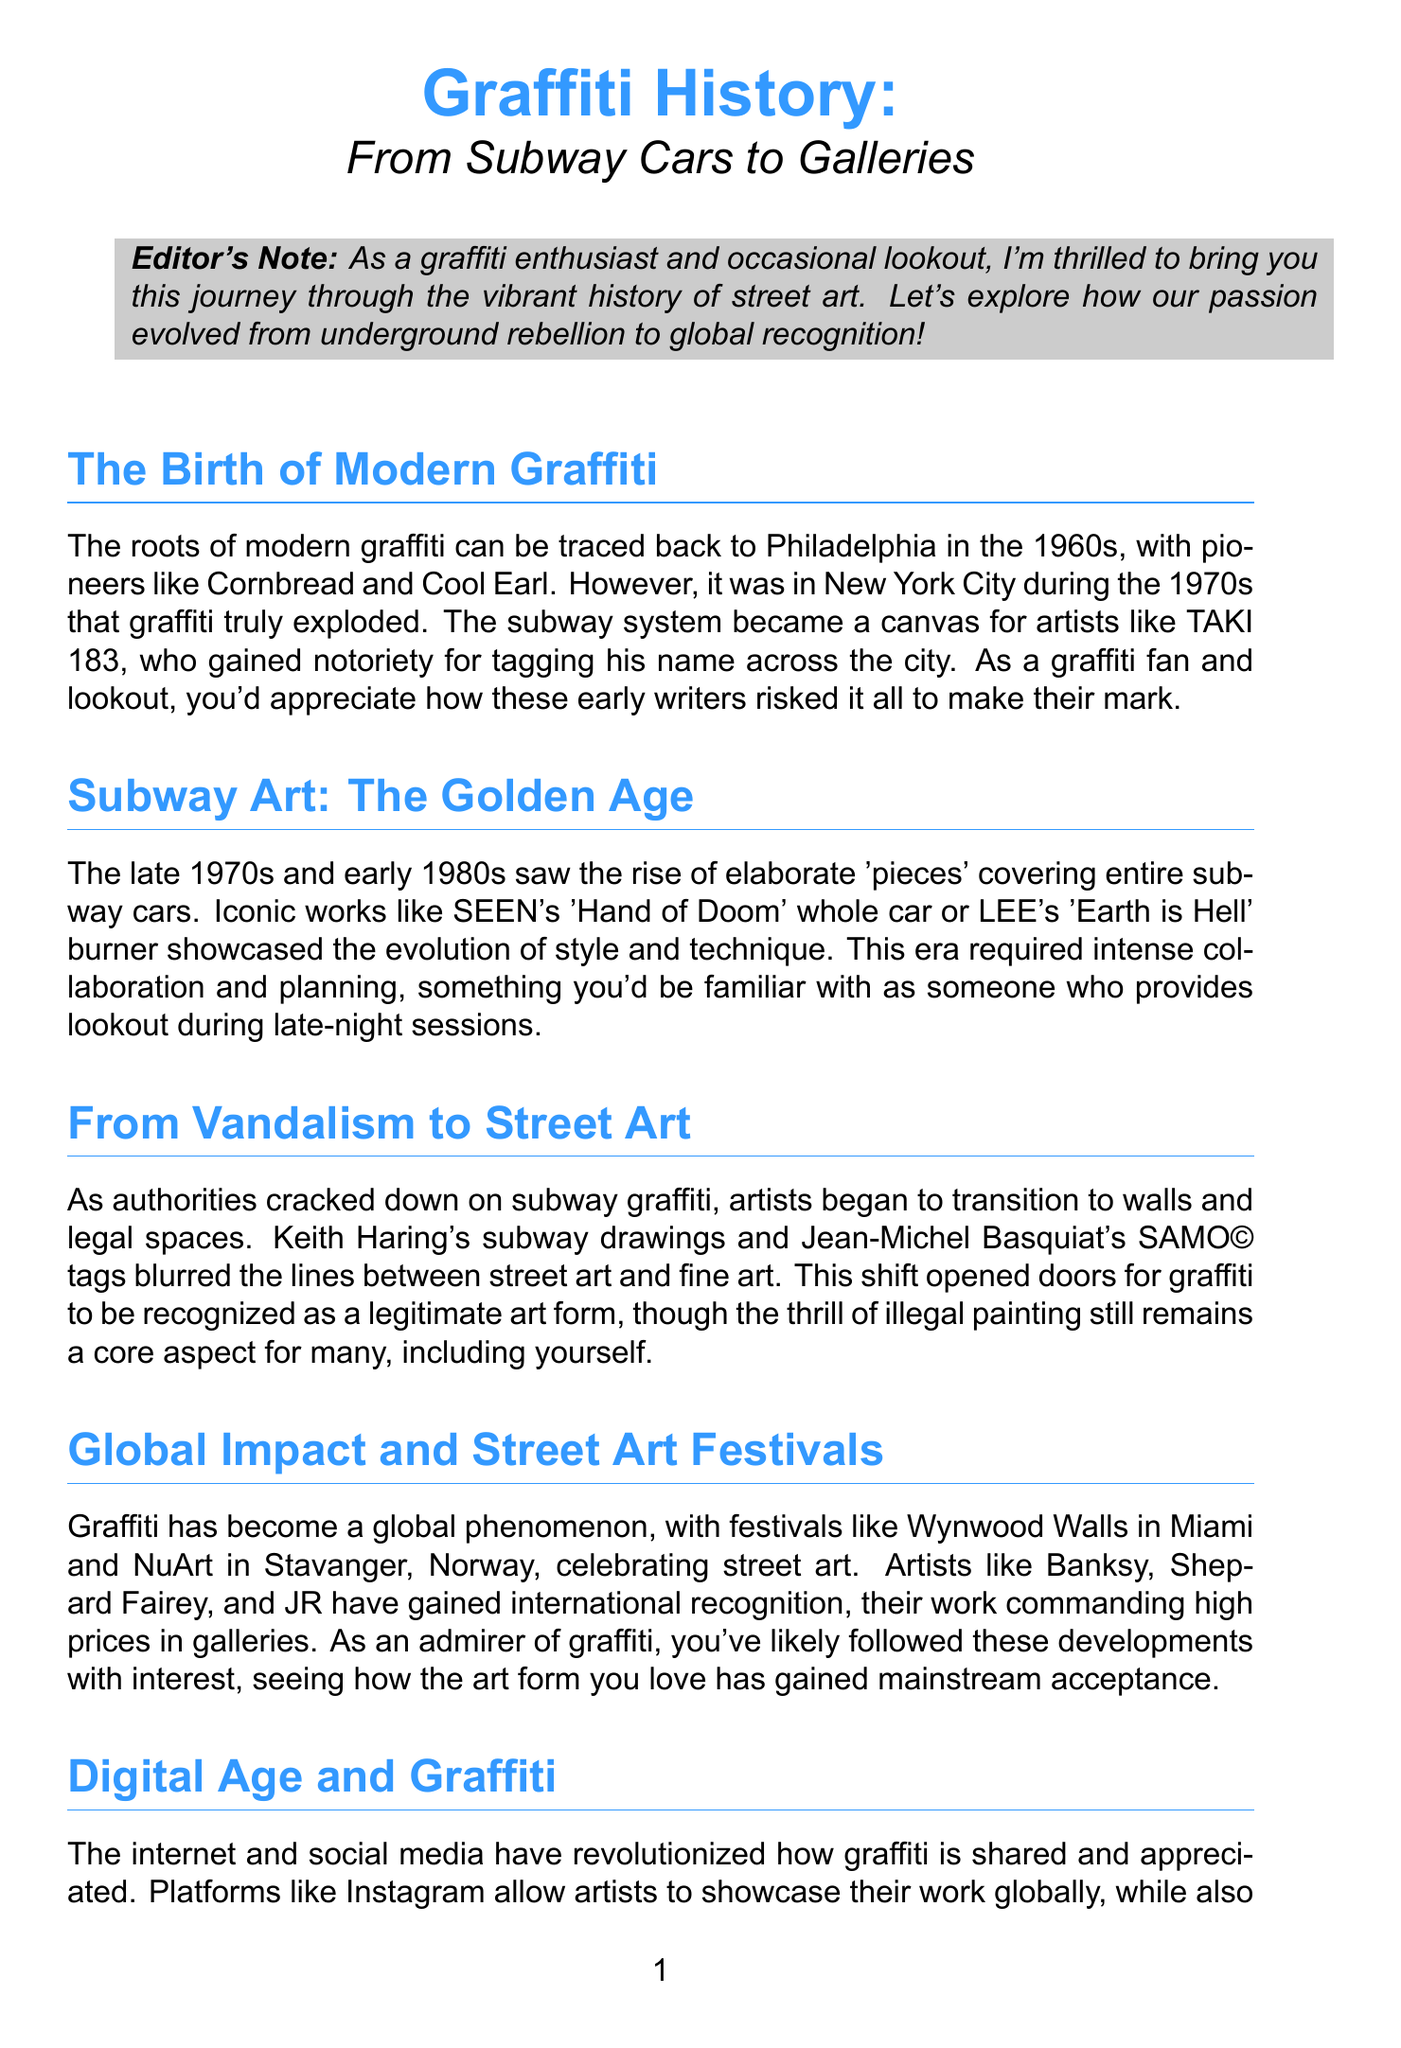What city is considered the birthplace of modern graffiti? The document states that the roots of modern graffiti can be traced back to Philadelphia in the 1960s.
Answer: Philadelphia Who is the artist known for the 'Hand of Doom' whole car? The document mentions SEEN as the artist behind this iconic piece.
Answer: SEEN What year did the whitewashing of 5 Pointz occur? According to the document, the whitewashing of 5 Pointz happened in 2013.
Answer: 2013 Which artist's subway drawings contributed to the transition of graffiti to street art? Keith Haring is specifically mentioned for his subway drawings in the document.
Answer: Keith Haring What global street art festival is mentioned in the document located in Miami? The document refers to Wynwood Walls as the street art festival celebrated in Miami.
Answer: Wynwood Walls How did social media impact the sharing of graffiti? The document explains that platforms like Instagram allow artists to showcase their work globally.
Answer: Globally What are NY Fats and Rusto Fats? These are described in the document as specialized caps for graffiti tools.
Answer: Specialized caps What iconic street artist is associated with the name Banksy? The document states that Banksy is an artist who has gained international recognition in graffiti.
Answer: Banksy What type of document is this? The format and content indicate that it is a newsletter about the history of graffiti.
Answer: Newsletter 